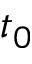Convert formula to latex. <formula><loc_0><loc_0><loc_500><loc_500>t _ { 0 }</formula> 